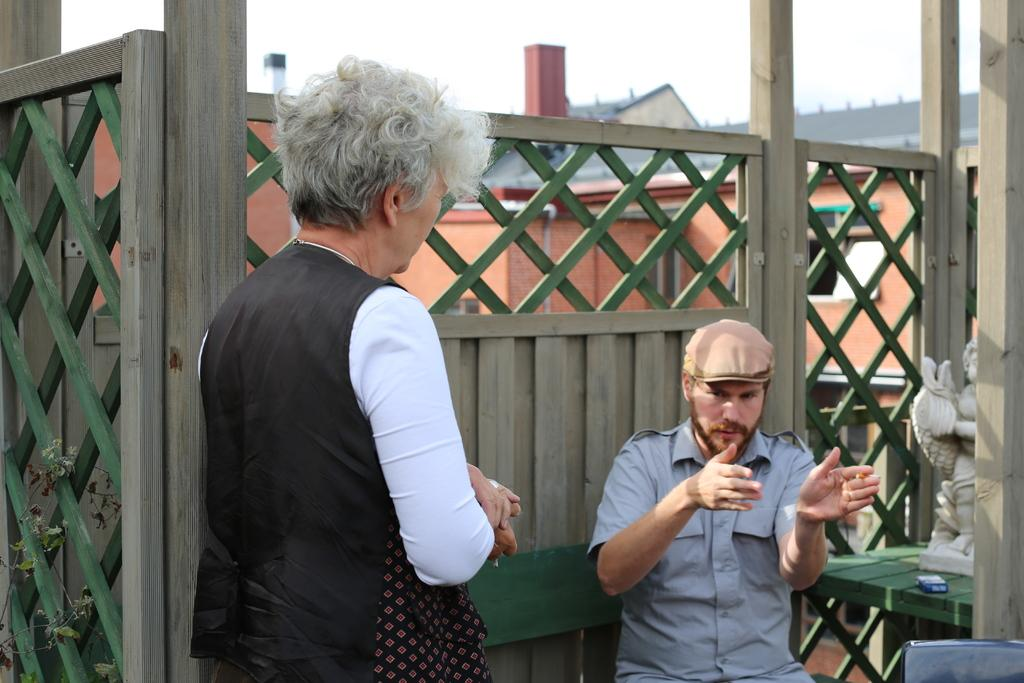What is the man in the image doing? The man is sitting on a bench in the image. What object can be seen on the table in the image? A statue is present on the table in the image. What else is on the table besides the statue? There is a box on the table. What type of structures can be seen in the image? There are buildings with windows in the image. What is the woman in the image doing? The woman is standing in the image. What can be seen in the background of the image? The sky is visible in the background of the image. How does the boat in the image affect the man sitting on the bench? There is no boat present in the image, so it cannot affect the man sitting on the bench. What type of sneeze does the statue on the table have? The statue is not capable of sneezing, as it is an inanimate object. 